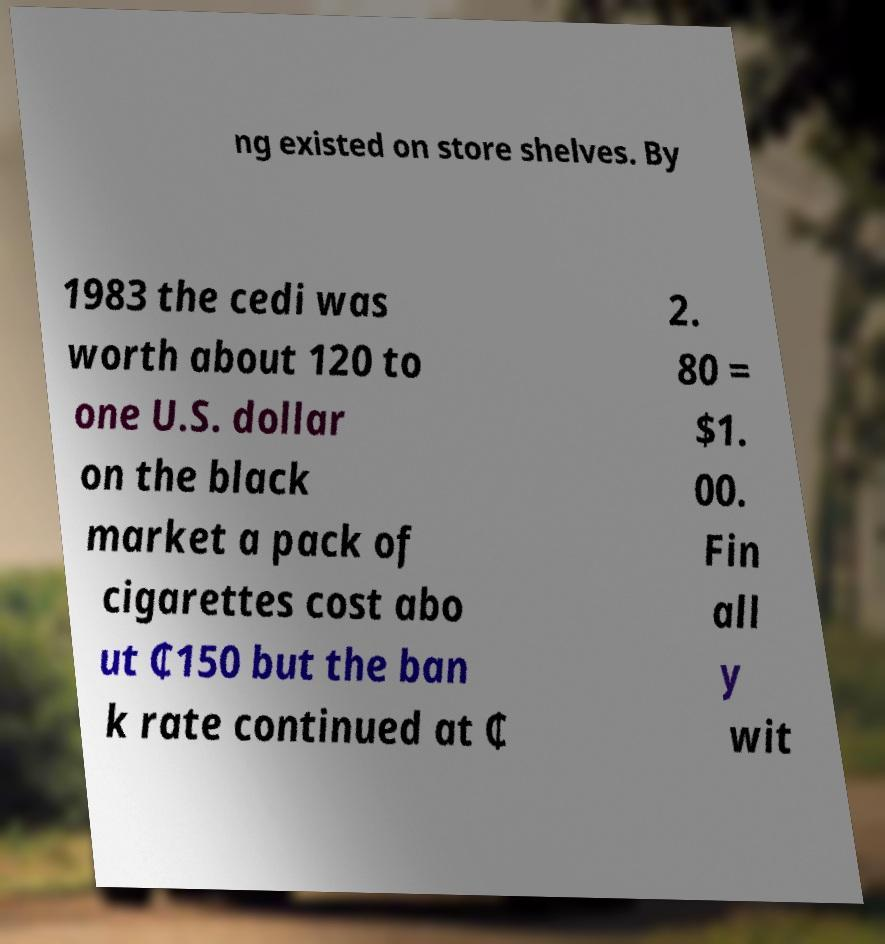Could you extract and type out the text from this image? ng existed on store shelves. By 1983 the cedi was worth about 120 to one U.S. dollar on the black market a pack of cigarettes cost abo ut ₵150 but the ban k rate continued at ₵ 2. 80 = $1. 00. Fin all y wit 